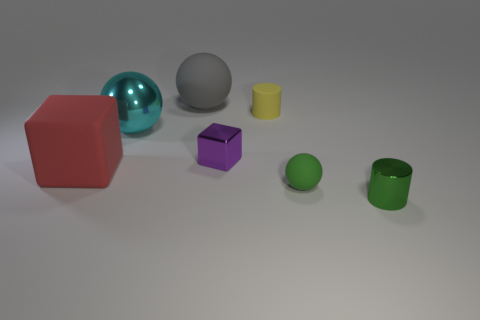There is a sphere that is the same material as the large gray thing; what color is it?
Your answer should be compact. Green. What material is the cylinder that is to the left of the shiny object that is in front of the large red object?
Offer a terse response. Rubber. What number of things are either rubber spheres right of the large matte sphere or small rubber spheres that are in front of the rubber cylinder?
Provide a short and direct response. 1. How big is the cylinder in front of the shiny thing that is left of the big rubber thing behind the large red object?
Provide a short and direct response. Small. Are there the same number of big rubber objects that are right of the big red cube and big matte blocks?
Your answer should be compact. Yes. There is a green metal thing; is its shape the same as the tiny metal object that is left of the green metal cylinder?
Provide a succinct answer. No. What size is the other metallic thing that is the same shape as the big gray object?
Your answer should be compact. Large. What number of other things are there of the same material as the large gray thing
Provide a succinct answer. 3. What is the tiny purple block made of?
Ensure brevity in your answer.  Metal. There is a metallic object that is in front of the large red matte block; does it have the same color as the sphere to the right of the gray matte object?
Provide a succinct answer. Yes. 